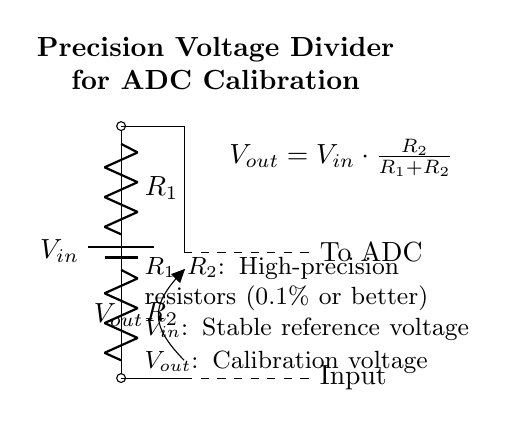What is the output voltage formula for this circuit? The output voltage is given by the formula \( V_{out} = V_{in} \cdot \frac{R_2}{R_1 + R_2} \), which is positioned in the diagram near the output. This formula shows how the output voltage is dependent on the input voltage and the resistance values.
Answer: Vout = Vin * R2 / (R1 + R2) What is the purpose of the resistors in this circuit? The resistors \( R_1 \) and \( R_2 \) form the voltage divider, where they reduce the input voltage \( V_{in} \) to a lower output voltage \( V_{out} \). Their precision is crucial for accurate calibration of the ADC.
Answer: To divide voltage What are the specifications for the resistors used? The circuit notes specify that \( R_1 \) and \( R_2 \) should be high-precision resistors with a tolerance of 0.1% or better, ensuring minimal deviation in the voltage divider output for accurate ADC calibration.
Answer: 0.1% tolerance What kind of power supply is used in this circuit? The circuit uses a battery as the power supply, indicated by the battery symbol and labeled as \( V_{in} \) at the top of the diagram. This provides a stable reference voltage necessary for the divider.
Answer: Battery What is the significance of the dashed lines in the circuit? The dashed lines indicate connections to other components or systems, specifically showing that \( V_{out} \) is connected to the ADC (analog-to-digital converter) for calibration purposes, demonstrating its role in the larger system.
Answer: To ADC What type of system is this voltage divider designed for? The voltage divider is specifically designed for calibrating analog-to-digital converters in legacy systems, ensuring that the ADCs convert analog signals accurately based on the precise output voltage.
Answer: Legacy systems 